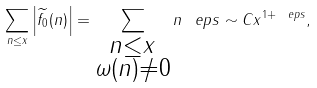<formula> <loc_0><loc_0><loc_500><loc_500>\sum _ { n \leq x } \left | \widetilde { f _ { 0 } } ( n ) \right | = \sum _ { \substack { n \leq x \\ \omega ( n ) \neq 0 } } n ^ { \ } e p s \sim C x ^ { 1 + \ e p s } ,</formula> 